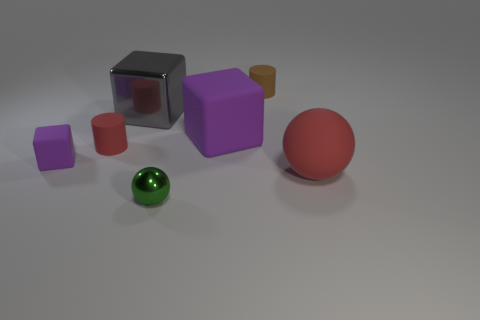Subtract all brown balls. Subtract all purple cylinders. How many balls are left? 2 Add 1 big gray matte balls. How many objects exist? 8 Subtract all cylinders. How many objects are left? 5 Add 3 small purple matte cubes. How many small purple matte cubes exist? 4 Subtract 0 brown balls. How many objects are left? 7 Subtract all red cubes. Subtract all tiny red objects. How many objects are left? 6 Add 6 green objects. How many green objects are left? 7 